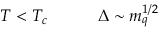Convert formula to latex. <formula><loc_0><loc_0><loc_500><loc_500>T < T _ { c } \Delta \sim m _ { q } ^ { 1 / 2 }</formula> 